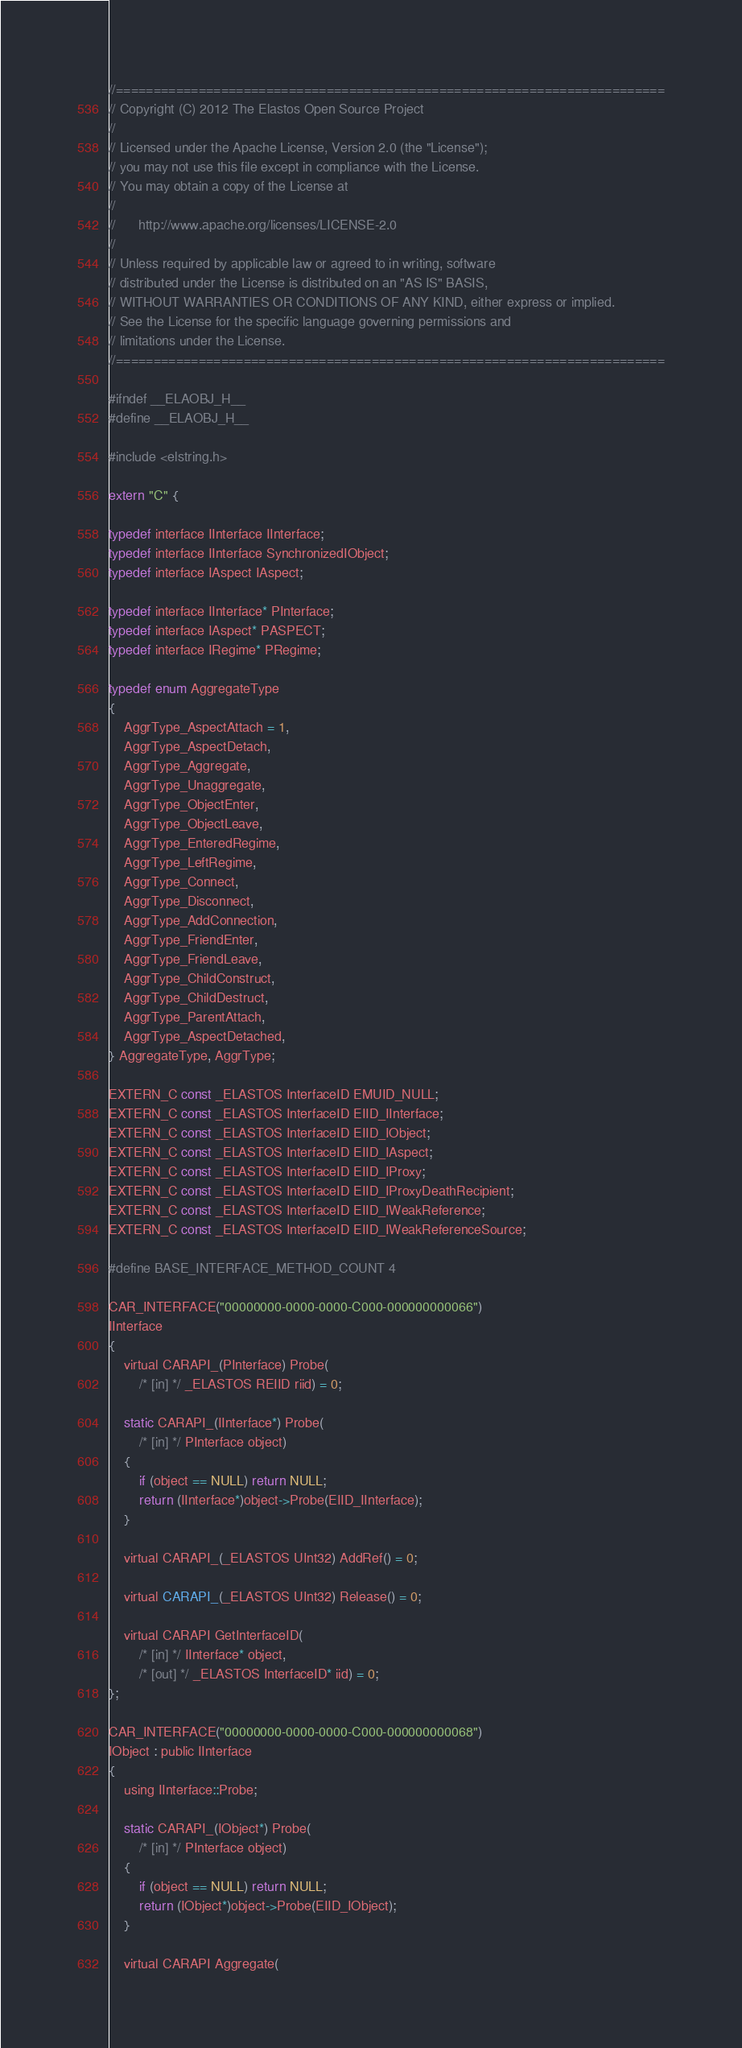Convert code to text. <code><loc_0><loc_0><loc_500><loc_500><_C_>//=========================================================================
// Copyright (C) 2012 The Elastos Open Source Project
//
// Licensed under the Apache License, Version 2.0 (the "License");
// you may not use this file except in compliance with the License.
// You may obtain a copy of the License at
//
//      http://www.apache.org/licenses/LICENSE-2.0
//
// Unless required by applicable law or agreed to in writing, software
// distributed under the License is distributed on an "AS IS" BASIS,
// WITHOUT WARRANTIES OR CONDITIONS OF ANY KIND, either express or implied.
// See the License for the specific language governing permissions and
// limitations under the License.
//=========================================================================

#ifndef __ELAOBJ_H__
#define __ELAOBJ_H__

#include <elstring.h>

extern "C" {

typedef interface IInterface IInterface;
typedef interface IInterface SynchronizedIObject;
typedef interface IAspect IAspect;

typedef interface IInterface* PInterface;
typedef interface IAspect* PASPECT;
typedef interface IRegime* PRegime;

typedef enum AggregateType
{
    AggrType_AspectAttach = 1,
    AggrType_AspectDetach,
    AggrType_Aggregate,
    AggrType_Unaggregate,
    AggrType_ObjectEnter,
    AggrType_ObjectLeave,
    AggrType_EnteredRegime,
    AggrType_LeftRegime,
    AggrType_Connect,
    AggrType_Disconnect,
    AggrType_AddConnection,
    AggrType_FriendEnter,
    AggrType_FriendLeave,
    AggrType_ChildConstruct,
    AggrType_ChildDestruct,
    AggrType_ParentAttach,
    AggrType_AspectDetached,
} AggregateType, AggrType;

EXTERN_C const _ELASTOS InterfaceID EMUID_NULL;
EXTERN_C const _ELASTOS InterfaceID EIID_IInterface;
EXTERN_C const _ELASTOS InterfaceID EIID_IObject;
EXTERN_C const _ELASTOS InterfaceID EIID_IAspect;
EXTERN_C const _ELASTOS InterfaceID EIID_IProxy;
EXTERN_C const _ELASTOS InterfaceID EIID_IProxyDeathRecipient;
EXTERN_C const _ELASTOS InterfaceID EIID_IWeakReference;
EXTERN_C const _ELASTOS InterfaceID EIID_IWeakReferenceSource;

#define BASE_INTERFACE_METHOD_COUNT 4

CAR_INTERFACE("00000000-0000-0000-C000-000000000066")
IInterface
{
    virtual CARAPI_(PInterface) Probe(
        /* [in] */ _ELASTOS REIID riid) = 0;

    static CARAPI_(IInterface*) Probe(
        /* [in] */ PInterface object)
    {
        if (object == NULL) return NULL;
        return (IInterface*)object->Probe(EIID_IInterface);
    }

    virtual CARAPI_(_ELASTOS UInt32) AddRef() = 0;

    virtual CARAPI_(_ELASTOS UInt32) Release() = 0;

    virtual CARAPI GetInterfaceID(
        /* [in] */ IInterface* object,
        /* [out] */ _ELASTOS InterfaceID* iid) = 0;
};

CAR_INTERFACE("00000000-0000-0000-C000-000000000068")
IObject : public IInterface
{
    using IInterface::Probe;

    static CARAPI_(IObject*) Probe(
        /* [in] */ PInterface object)
    {
        if (object == NULL) return NULL;
        return (IObject*)object->Probe(EIID_IObject);
    }

    virtual CARAPI Aggregate(</code> 